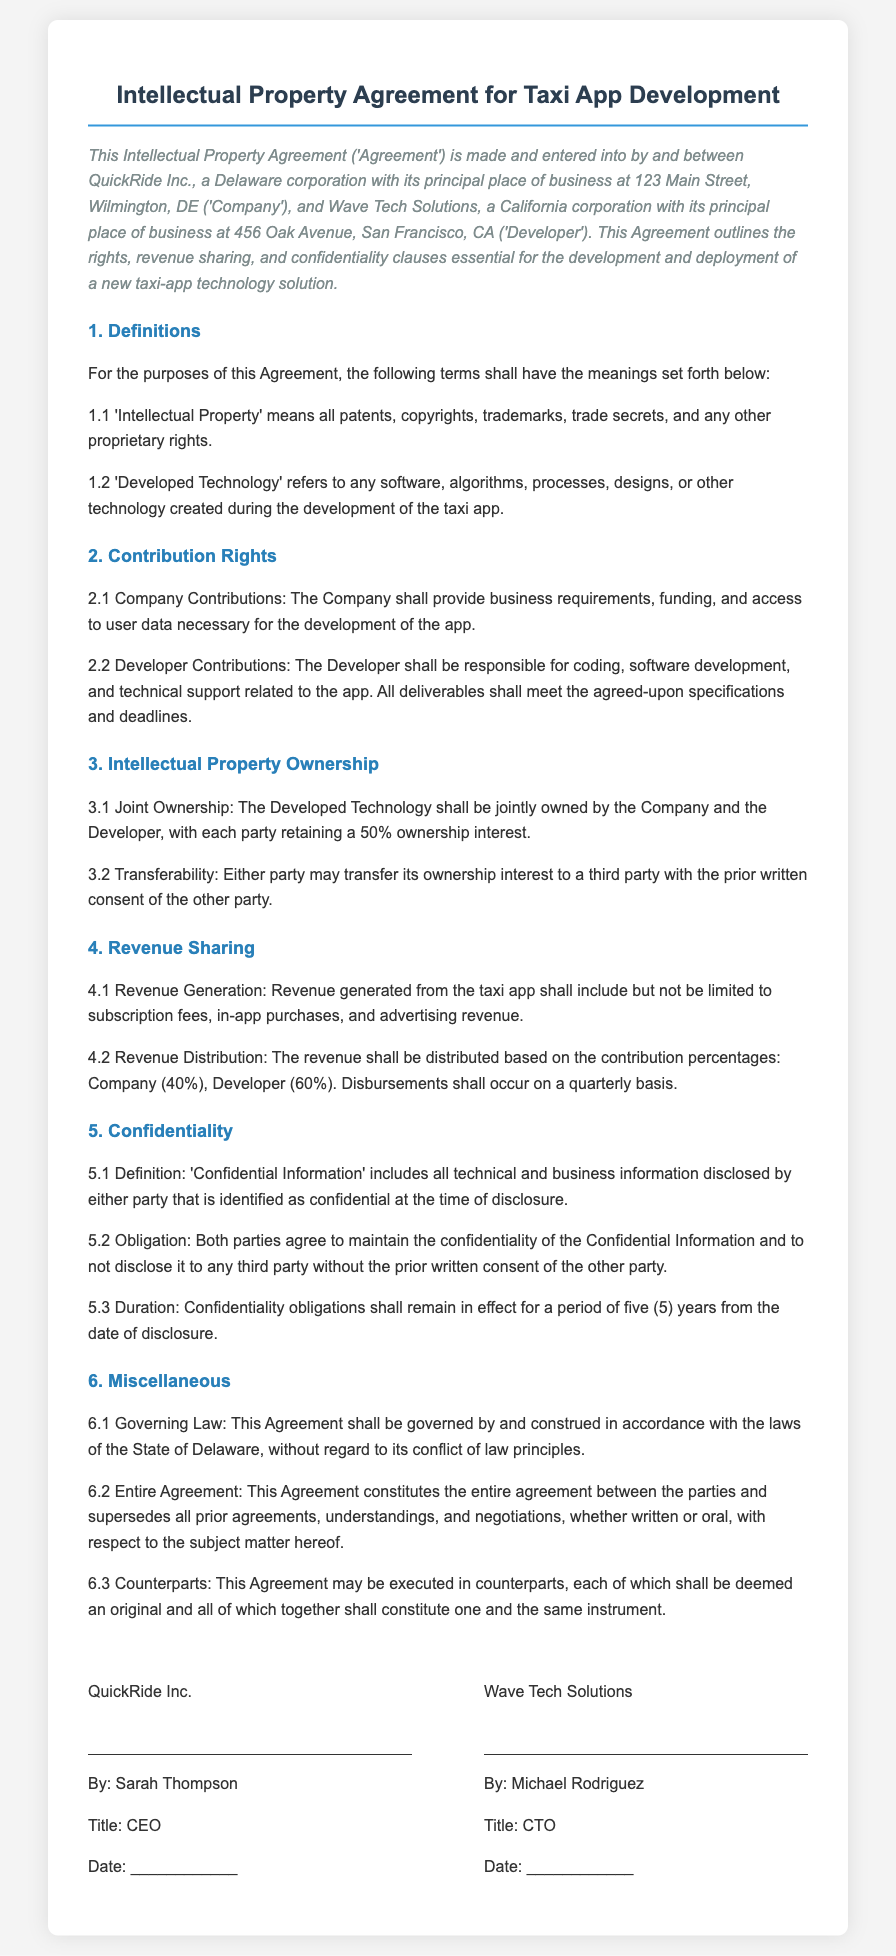What is the name of the Company? The document states that QuickRide Inc. is the name of the Company.
Answer: QuickRide Inc What is the address of the Developer? The address of Wave Tech Solutions, as mentioned in the document, is located at 456 Oak Avenue, San Francisco, CA.
Answer: 456 Oak Avenue, San Francisco, CA What percentage of revenue does the Company receive? According to the revenue sharing section, the Company receives 40% of the revenue generated from the taxi app.
Answer: 40% What is the duration of confidentiality obligations? The document specifies that confidentiality obligations last for a period of five years from the date of disclosure.
Answer: five years Who is the CEO of QuickRide Inc.? The document lists Sarah Thompson as the CEO of QuickRide Inc.
Answer: Sarah Thompson What type of ownership is established for Developed Technology? The document states that Developed Technology will be jointly owned by both parties.
Answer: jointly owned What must be obtained before transferring ownership? The document requires prior written consent from the other party before ownership transfer.
Answer: prior written consent What is included under 'Confidential Information'? The document defines Confidential Information as all technical and business information disclosed and identified as confidential.
Answer: all technical and business information What is the governing law for this Agreement? The governing law for the Agreement, as mentioned, is the laws of the State of Delaware.
Answer: State of Delaware 